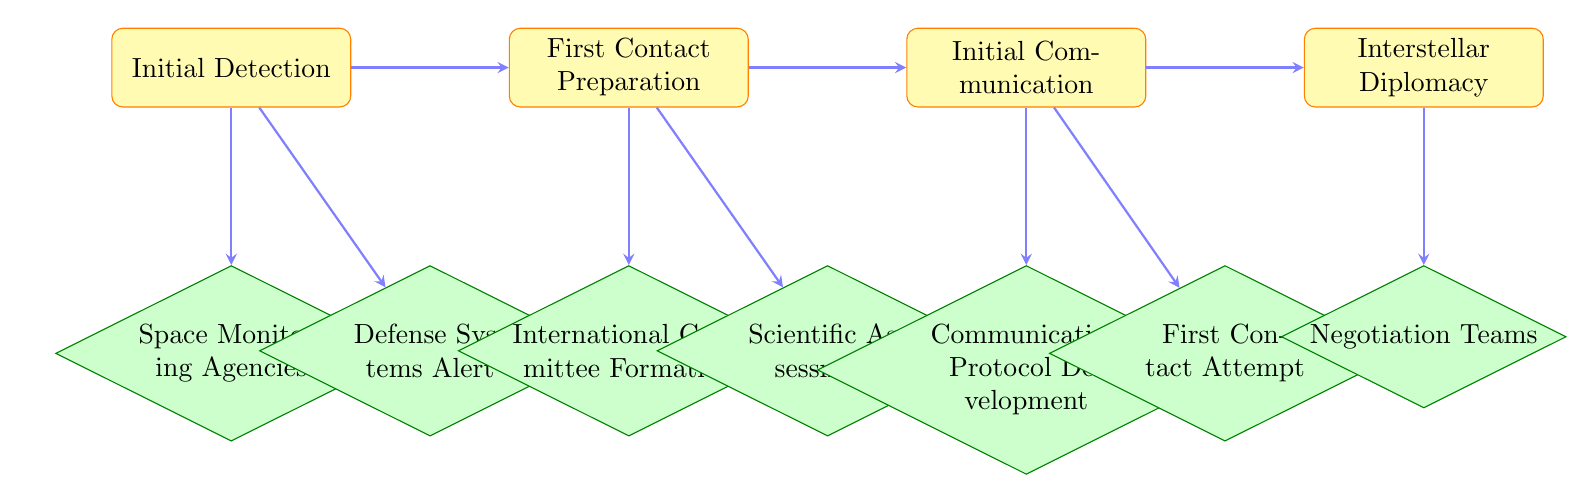What is the first step in the flow chart? The flow chart begins with the "Initial Detection" step. This is identifiable as the first node at the top of the diagram, indicating that this is where the process starts.
Answer: Initial Detection How many main stages are in the protocol? The flow chart has four main stages: Initial Detection, First Contact Preparation, Initial Communication, and Interstellar Diplomacy. To find this, I counted the number of labeled process nodes in the diagram.
Answer: Four Which entity is responsible for scientific assessment? The "Scientific Assessment" action is conducted by the "SETI Institute and global scientific bodies," which is specified in the corresponding node under the "First Contact Preparation" stage of the flow chart.
Answer: SETI Institute and global scientific bodies What follows the "Initial Communication" step? After the "Initial Communication," the next stage in the flow chart is "Interstellar Diplomacy." This is determined by following the directional arrows indicating the flow of the protocol.
Answer: Interstellar Diplomacy What action occurs after "Defense Systems Alert"? Following "Defense Systems Alert," the next action linked to it is "First Contact Preparation." This indicates a sequence where defense alerts lead into diplomatic preparedness following detection of extraterrestrial signals.
Answer: First Contact Preparation Which nodes are part of the "Interstellar Diplomacy" stage? The nodes in the "Interstellar Diplomacy" stage include "Negotiation Teams," "Cultural Exchange Programs," and "Bilateral Agreements." By observing the connections from the "Interstellar Diplomacy" process node, these nodes can be identified.
Answer: Negotiation Teams, Cultural Exchange Programs, Bilateral Agreements Who sends the initial message or signal? The task of sending the initial message or signal is assigned to the "UN Council Representative," as indicated in the flow chart under the "Initial Communication" step.
Answer: UN Council Representative Which decision node comes after "Scientific Assessment"? The node that follows "Scientific Assessment" in the flow chart is "Communication Protocol Development." This order is established by the directional arrows connecting the nodes.
Answer: Communication Protocol Development 